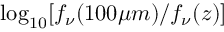Convert formula to latex. <formula><loc_0><loc_0><loc_500><loc_500>\log _ { 1 0 } [ f _ { \nu } ( 1 0 0 \mu m ) / f _ { \nu } ( z ) ]</formula> 